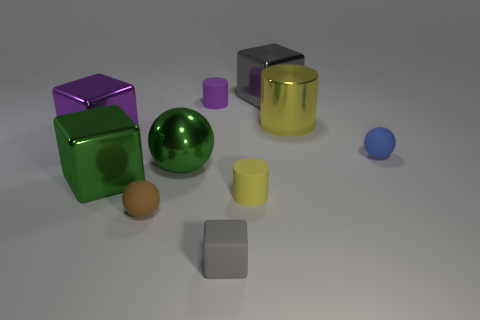What is the shape of the small yellow object that is made of the same material as the tiny blue object? cylinder 